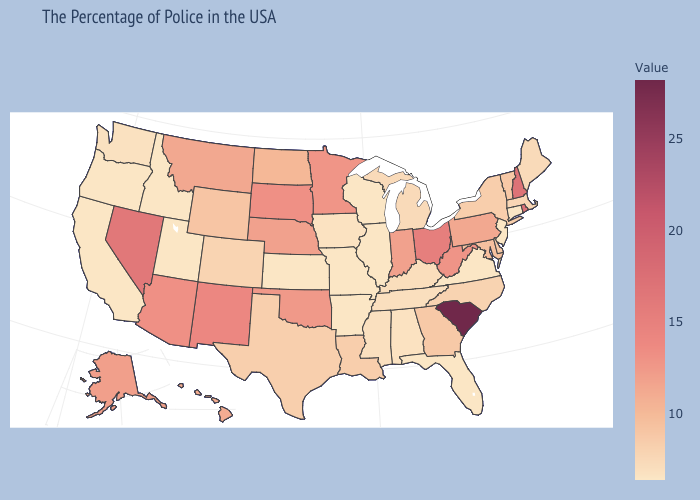Which states have the highest value in the USA?
Short answer required. South Carolina. Among the states that border Massachusetts , does New York have the highest value?
Quick response, please. No. Does the map have missing data?
Short answer required. No. Which states hav the highest value in the Northeast?
Quick response, please. Rhode Island. Does South Carolina have the lowest value in the South?
Be succinct. No. Does the map have missing data?
Answer briefly. No. Among the states that border Wisconsin , does Minnesota have the highest value?
Write a very short answer. Yes. 